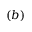<formula> <loc_0><loc_0><loc_500><loc_500>( b )</formula> 